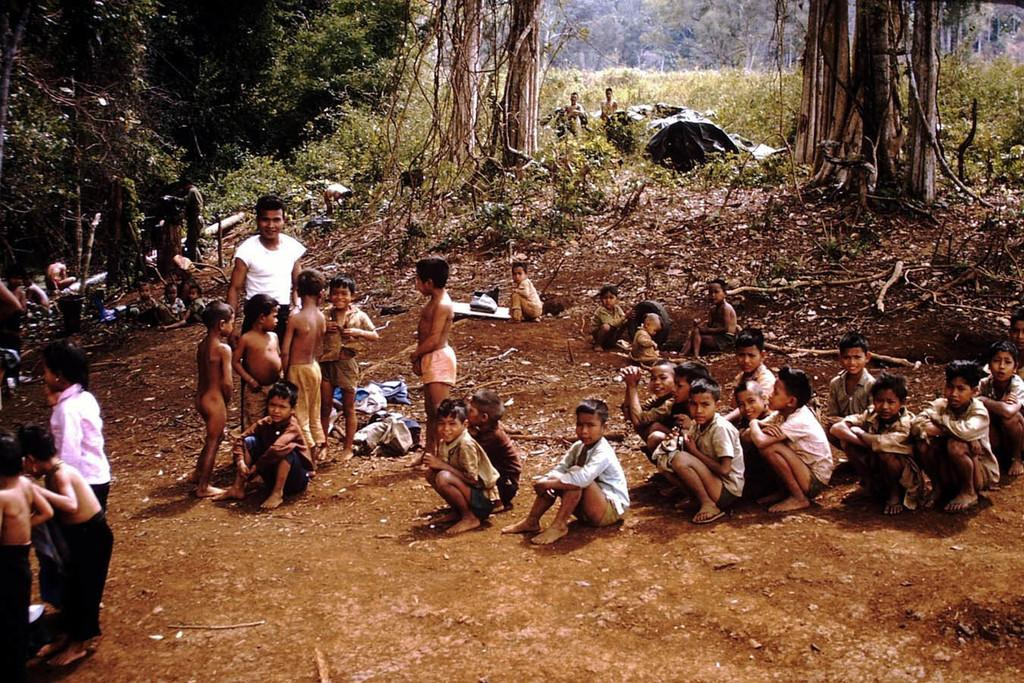What are the persons in the foreground of the image doing? The persons in the foreground of the image are sitting, standing, and squatting. Where are the persons located in the image? The persons are on the ground in the foreground of the image. What can be seen in the background of the image? In the background, there appears to be a shelter and greenery. How many persons are standing in the background? There are two persons standing in the background. What type of silk is being used for punishment in the image? There is no silk or punishment present in the image. What organization is responsible for the gathering of persons in the image? There is no organization mentioned or implied in the image. 